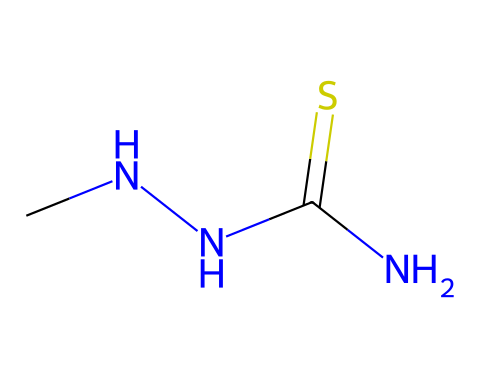What is the main functional group in thiosemicarbazide? The chemical structure contains a thiocarbonyl group (C=S) and an amine group (NH2). The presence of the thiocarbonyl indicates the main functional group.
Answer: thiocarbonyl How many nitrogen atoms are in thiosemicarbazide? By analyzing the SMILES representation, there are two nitrogen atoms (N) present in the structure.
Answer: two What type of bond is primarily found between the carbon atom and the sulfur atom? The bond between the carbon and sulfur in the thiocarbonyl group is a double bond, indicated by the "=" in the SMILES representation.
Answer: double bond Does thiosemicarbazide show basic or acidic properties? The presence of nitrogen atoms in this molecule typically gives it basic properties, due to the lone pair on nitrogen being available for protonation.
Answer: basic How many total atoms are in thiosemicarbazide? The SMILES notation reveals a total of 5 atoms: 1 carbon, 1 sulfur, and 3 nitrogen atoms.
Answer: five What type of compound is thiosemicarbazide classified as? Given its structure, thiosemicarbazide is classified as a thiosemicarbazide, part of the hydrazine derivatives family.
Answer: thiosemicarbazide 